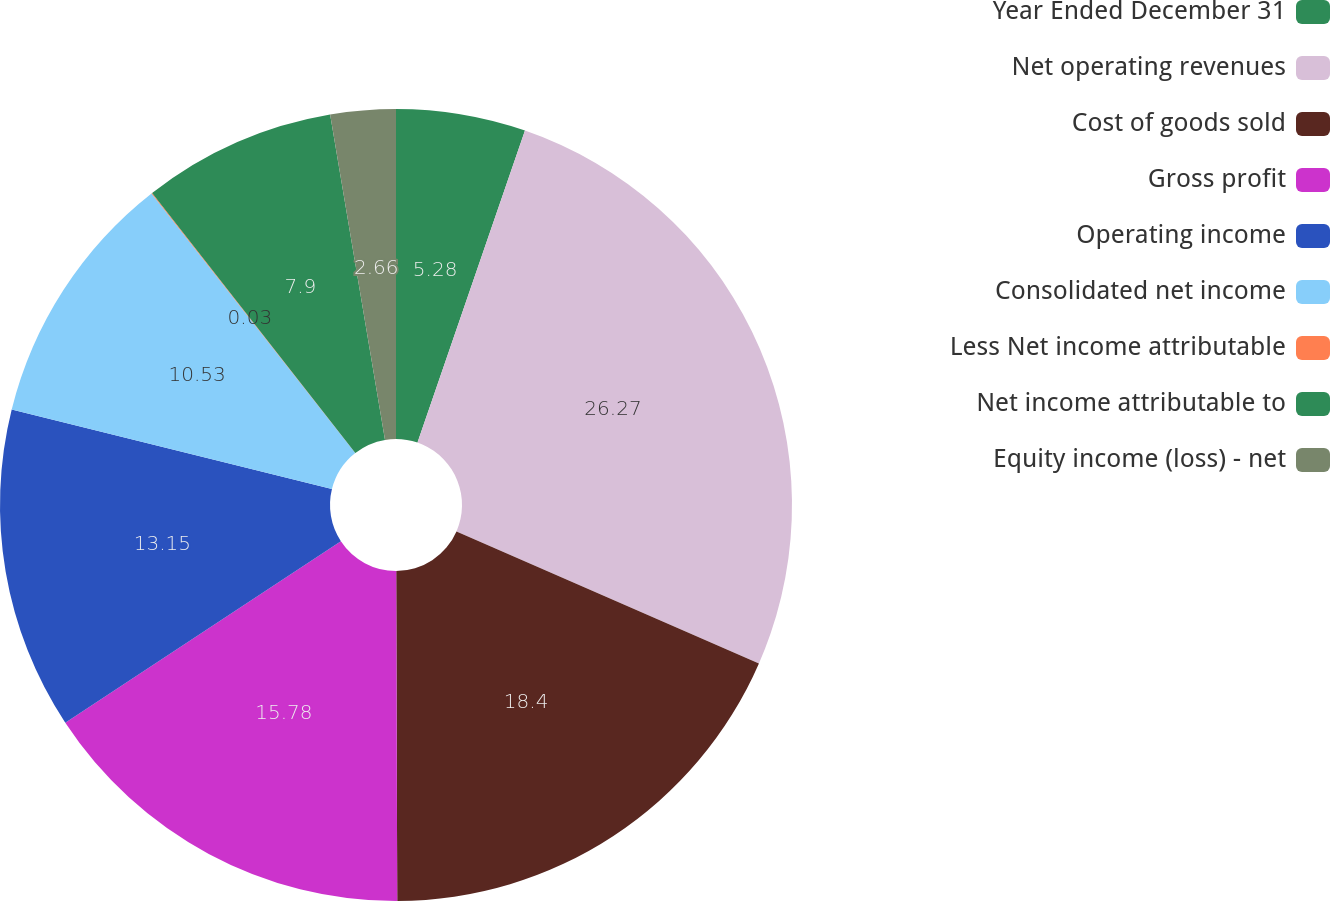Convert chart to OTSL. <chart><loc_0><loc_0><loc_500><loc_500><pie_chart><fcel>Year Ended December 31<fcel>Net operating revenues<fcel>Cost of goods sold<fcel>Gross profit<fcel>Operating income<fcel>Consolidated net income<fcel>Less Net income attributable<fcel>Net income attributable to<fcel>Equity income (loss) - net<nl><fcel>5.28%<fcel>26.27%<fcel>18.4%<fcel>15.78%<fcel>13.15%<fcel>10.53%<fcel>0.03%<fcel>7.9%<fcel>2.66%<nl></chart> 